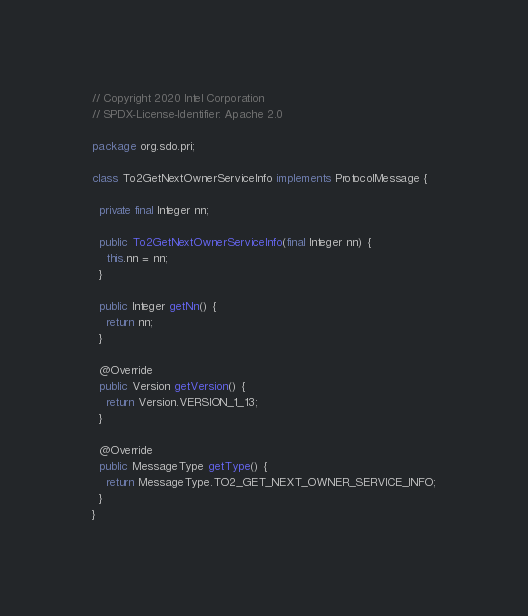Convert code to text. <code><loc_0><loc_0><loc_500><loc_500><_Java_>// Copyright 2020 Intel Corporation
// SPDX-License-Identifier: Apache 2.0

package org.sdo.pri;

class To2GetNextOwnerServiceInfo implements ProtocolMessage {

  private final Integer nn;

  public To2GetNextOwnerServiceInfo(final Integer nn) {
    this.nn = nn;
  }

  public Integer getNn() {
    return nn;
  }

  @Override
  public Version getVersion() {
    return Version.VERSION_1_13;
  }

  @Override
  public MessageType getType() {
    return MessageType.TO2_GET_NEXT_OWNER_SERVICE_INFO;
  }
}
</code> 